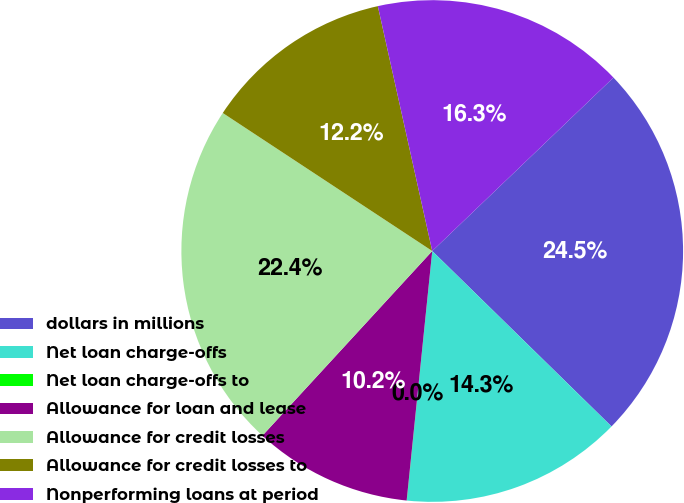<chart> <loc_0><loc_0><loc_500><loc_500><pie_chart><fcel>dollars in millions<fcel>Net loan charge-offs<fcel>Net loan charge-offs to<fcel>Allowance for loan and lease<fcel>Allowance for credit losses<fcel>Allowance for credit losses to<fcel>Nonperforming loans at period<nl><fcel>24.48%<fcel>14.29%<fcel>0.01%<fcel>10.21%<fcel>22.44%<fcel>12.25%<fcel>16.33%<nl></chart> 